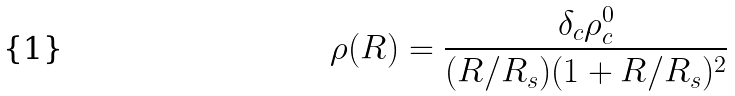Convert formula to latex. <formula><loc_0><loc_0><loc_500><loc_500>\rho ( R ) = \frac { \delta _ { c } \rho _ { c } ^ { 0 } } { ( R / R _ { s } ) ( 1 + R / R _ { s } ) ^ { 2 } }</formula> 